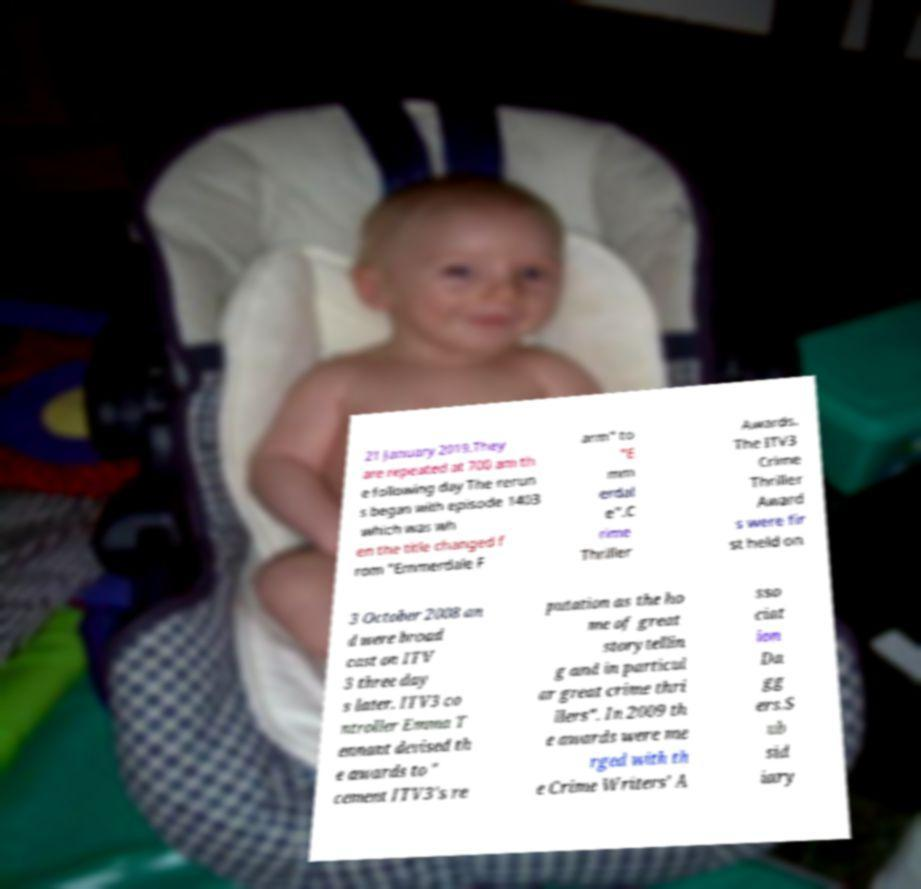Can you read and provide the text displayed in the image?This photo seems to have some interesting text. Can you extract and type it out for me? 21 January 2019.They are repeated at 700 am th e following day The rerun s began with episode 1403 which was wh en the title changed f rom "Emmerdale F arm" to "E mm erdal e".C rime Thriller Awards. The ITV3 Crime Thriller Award s were fir st held on 3 October 2008 an d were broad cast on ITV 3 three day s later. ITV3 co ntroller Emma T ennant devised th e awards to " cement ITV3's re putation as the ho me of great storytellin g and in particul ar great crime thri llers". In 2009 th e awards were me rged with th e Crime Writers' A sso ciat ion Da gg ers.S ub sid iary 